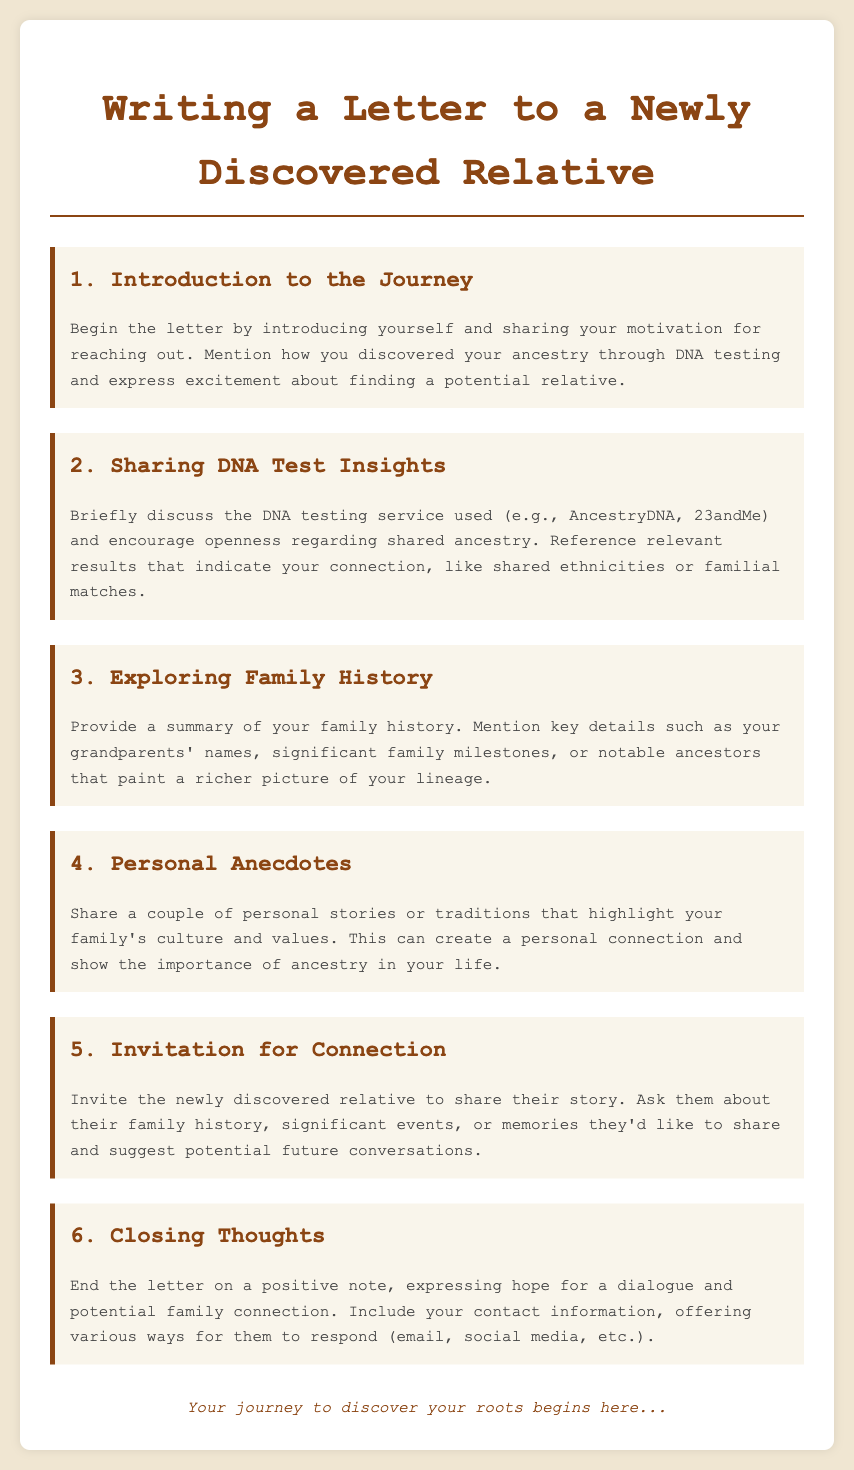What is the title of the document? The title of the document is clearly indicated at the top of the rendered page.
Answer: Writing a Letter to a Newly Discovered Relative What is the first agenda item? The first agenda item is mentioned under the section headings right below the title.
Answer: Introduction to the Journey How many agenda items are included? The total number of agenda items is found by counting them in the document.
Answer: Six Which DNA testing services are referenced? The document briefly mentions specific DNA testing services as examples.
Answer: AncestryDNA, 23andMe What should you include in the closing thoughts? The details on closing thoughts are laid out in the agenda item's description.
Answer: Hope for a dialogue What is one way to encourage connection with the relative? The text suggests how to invite the relative to share their story in the letter.
Answer: Ask them about their family history 